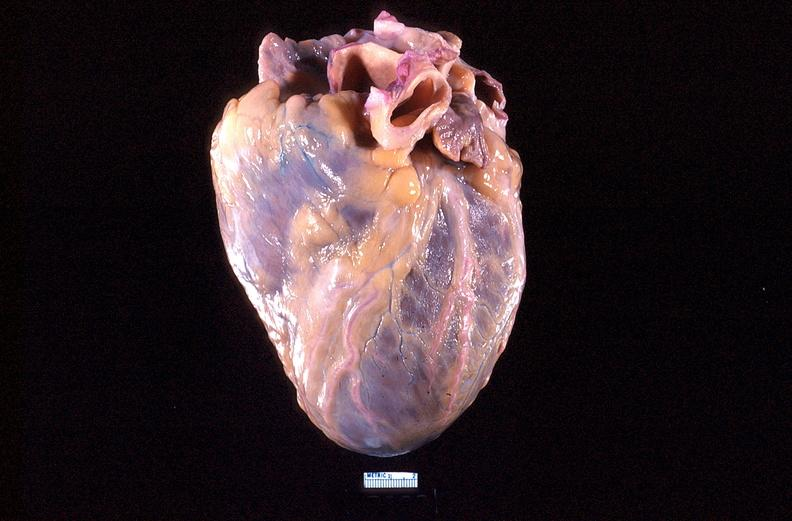what does this image show?
Answer the question using a single word or phrase. Heart 